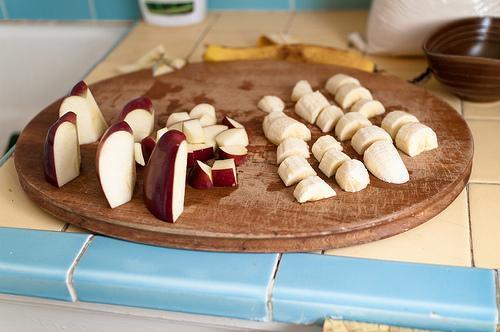How many different fruits are in this photo?
Give a very brief answer. 2. 